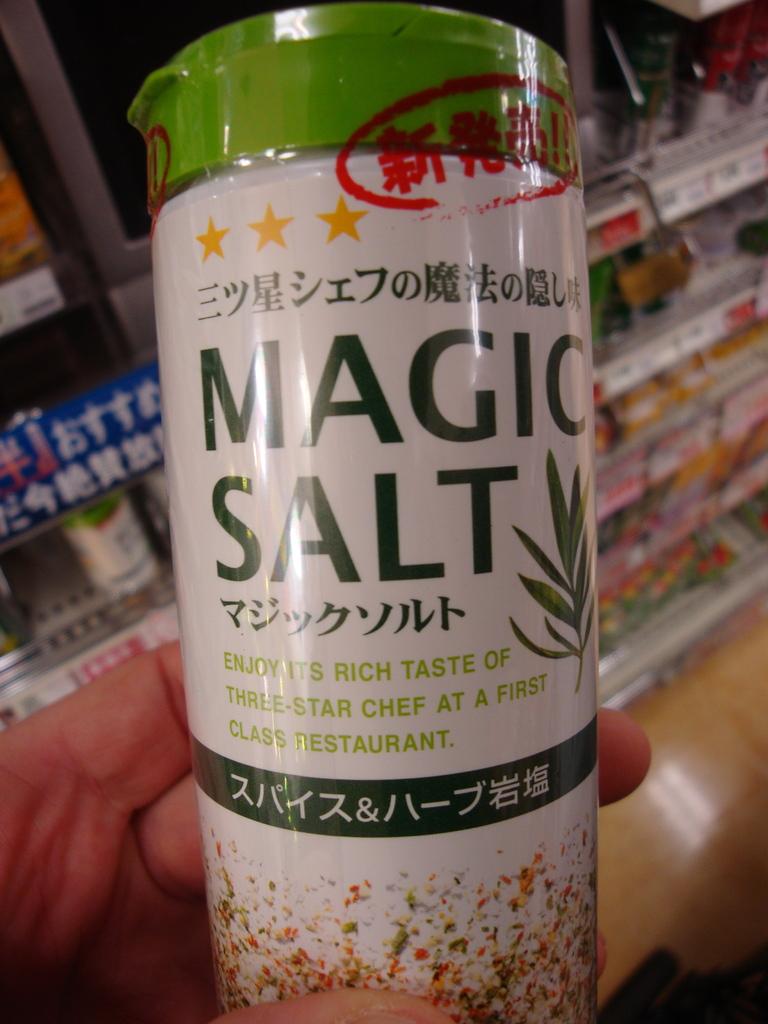What is magic?
Provide a succinct answer. Salt. What kind of salt is it?
Provide a succinct answer. Magic. 